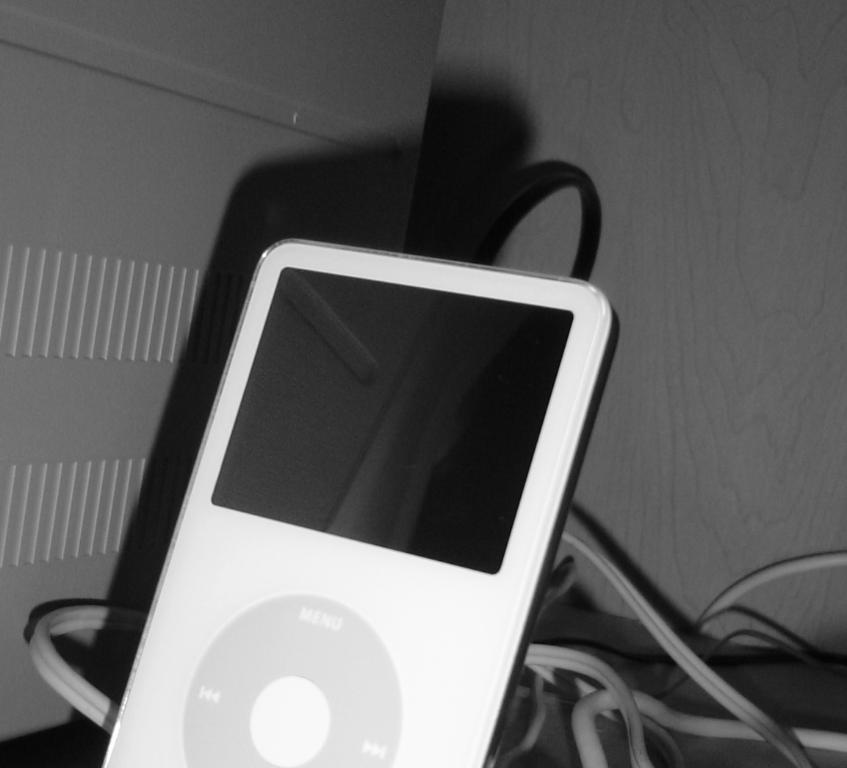What type of object can be seen in the image? There is an electronic device in the image. What else is visible in the image besides the electronic device? There are wires visible in the image. What can be seen in the background of the image? There is a wall in the background of the image. Where is the grain stored in the image? There is no grain present in the image. What type of notebook is visible on the shelf in the image? There is no shelf or notebook present in the image. 